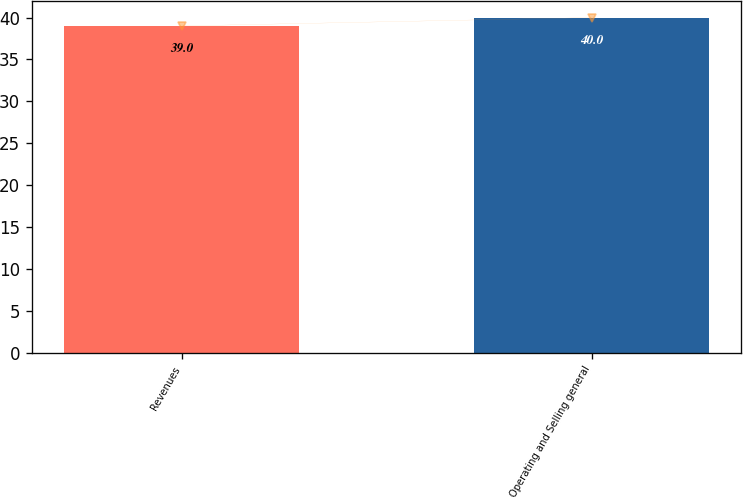Convert chart to OTSL. <chart><loc_0><loc_0><loc_500><loc_500><bar_chart><fcel>Revenues<fcel>Operating and Selling general<nl><fcel>39<fcel>40<nl></chart> 